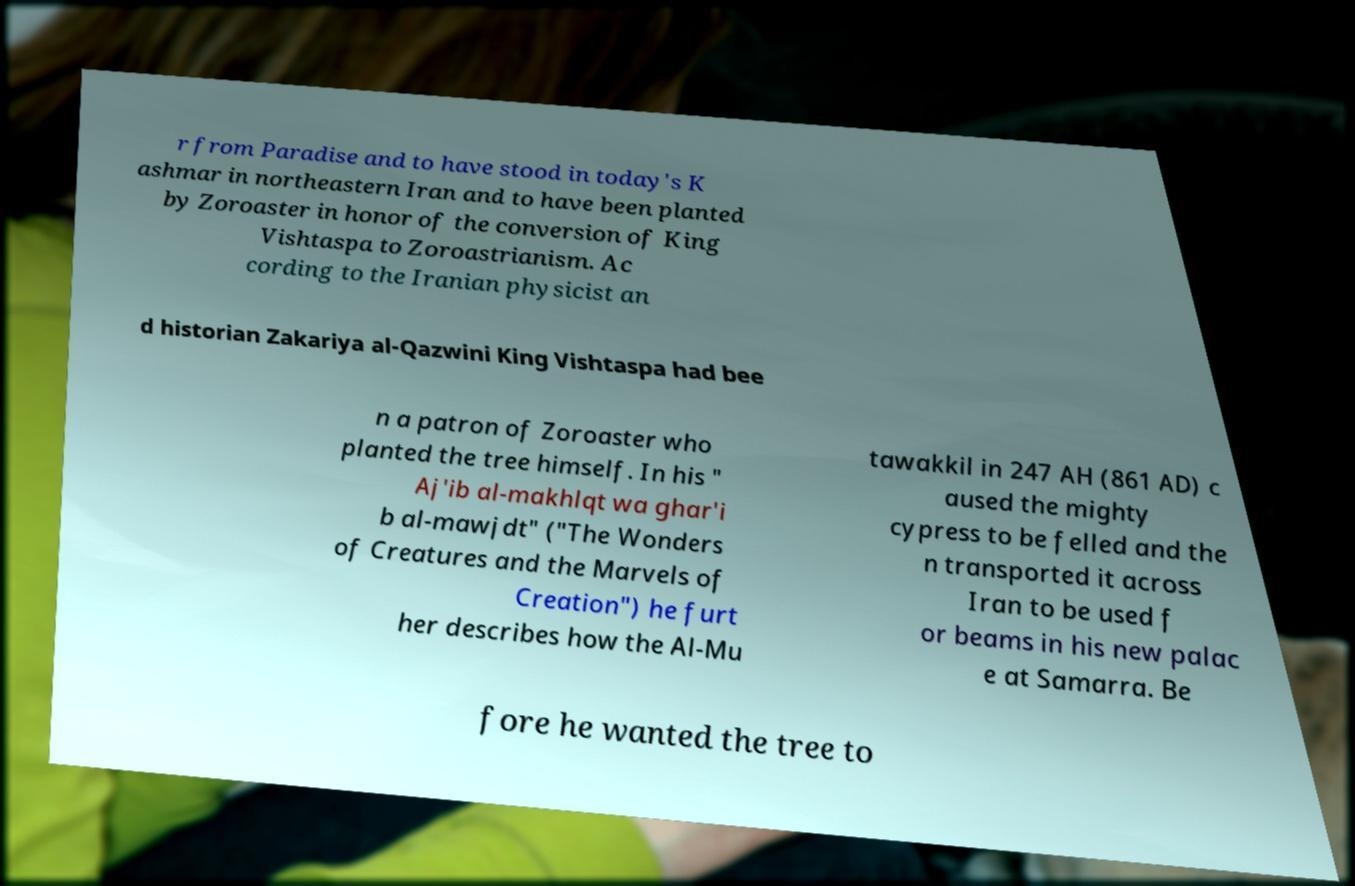I need the written content from this picture converted into text. Can you do that? r from Paradise and to have stood in today's K ashmar in northeastern Iran and to have been planted by Zoroaster in honor of the conversion of King Vishtaspa to Zoroastrianism. Ac cording to the Iranian physicist an d historian Zakariya al-Qazwini King Vishtaspa had bee n a patron of Zoroaster who planted the tree himself. In his " Aj'ib al-makhlqt wa ghar'i b al-mawjdt" ("The Wonders of Creatures and the Marvels of Creation") he furt her describes how the Al-Mu tawakkil in 247 AH (861 AD) c aused the mighty cypress to be felled and the n transported it across Iran to be used f or beams in his new palac e at Samarra. Be fore he wanted the tree to 